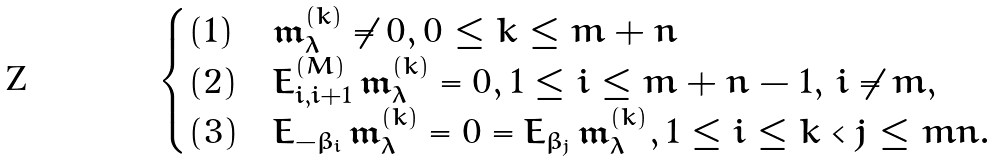<formula> <loc_0><loc_0><loc_500><loc_500>\begin{cases} ( 1 ) & \mathfrak { m } _ { \lambda } ^ { ( k ) } \neq 0 , 0 \leq k \leq m + n \\ ( 2 ) & E _ { i , i + 1 } ^ { ( M ) } \, \mathfrak { m } _ { \lambda } ^ { ( k ) } = 0 , 1 \leq i \leq m + n - 1 , \, i \neq m , \\ ( 3 ) & E _ { - \beta _ { i } } \, \mathfrak { m } _ { \lambda } ^ { ( k ) } = 0 = E _ { \beta _ { j } } \, \mathfrak { m } _ { \lambda } ^ { ( k ) } , 1 \leq i \leq k < j \leq m n . \end{cases}</formula> 